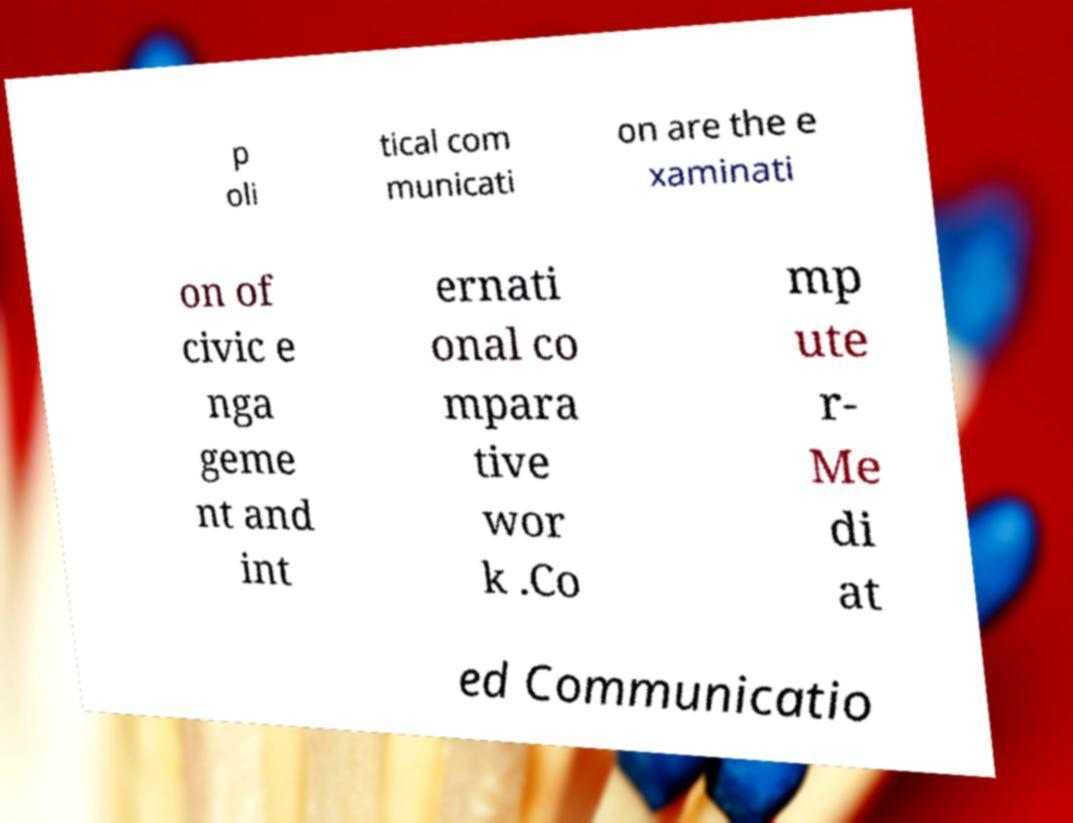Please read and relay the text visible in this image. What does it say? p oli tical com municati on are the e xaminati on of civic e nga geme nt and int ernati onal co mpara tive wor k .Co mp ute r- Me di at ed Communicatio 